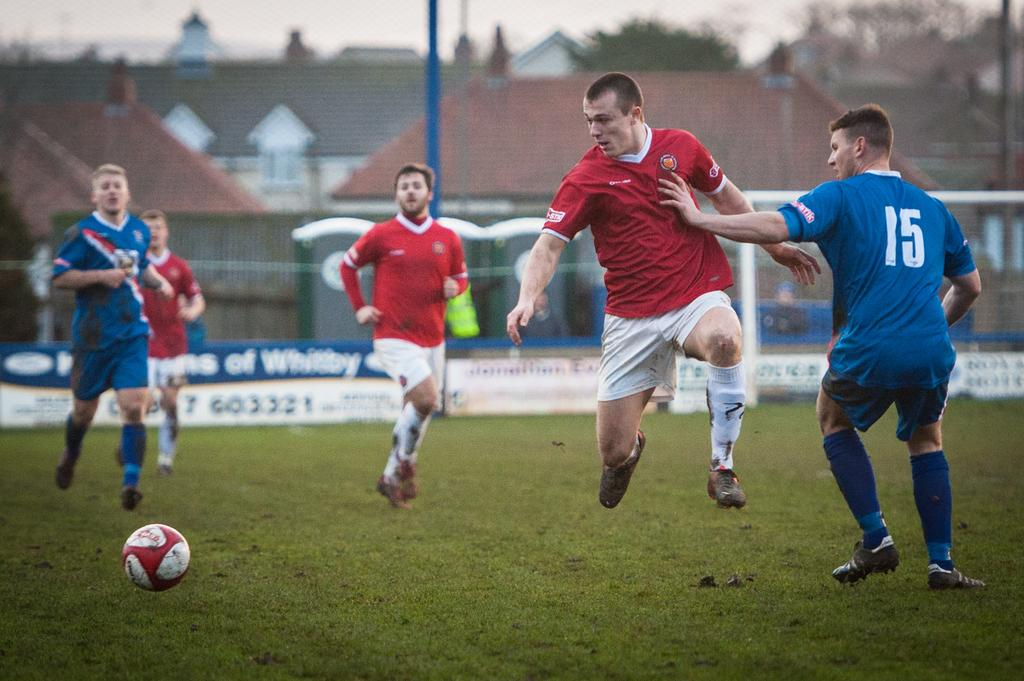Provide a one-sentence caption for the provided image. Blue and white Jersey with the number fifteen in white on the back. 